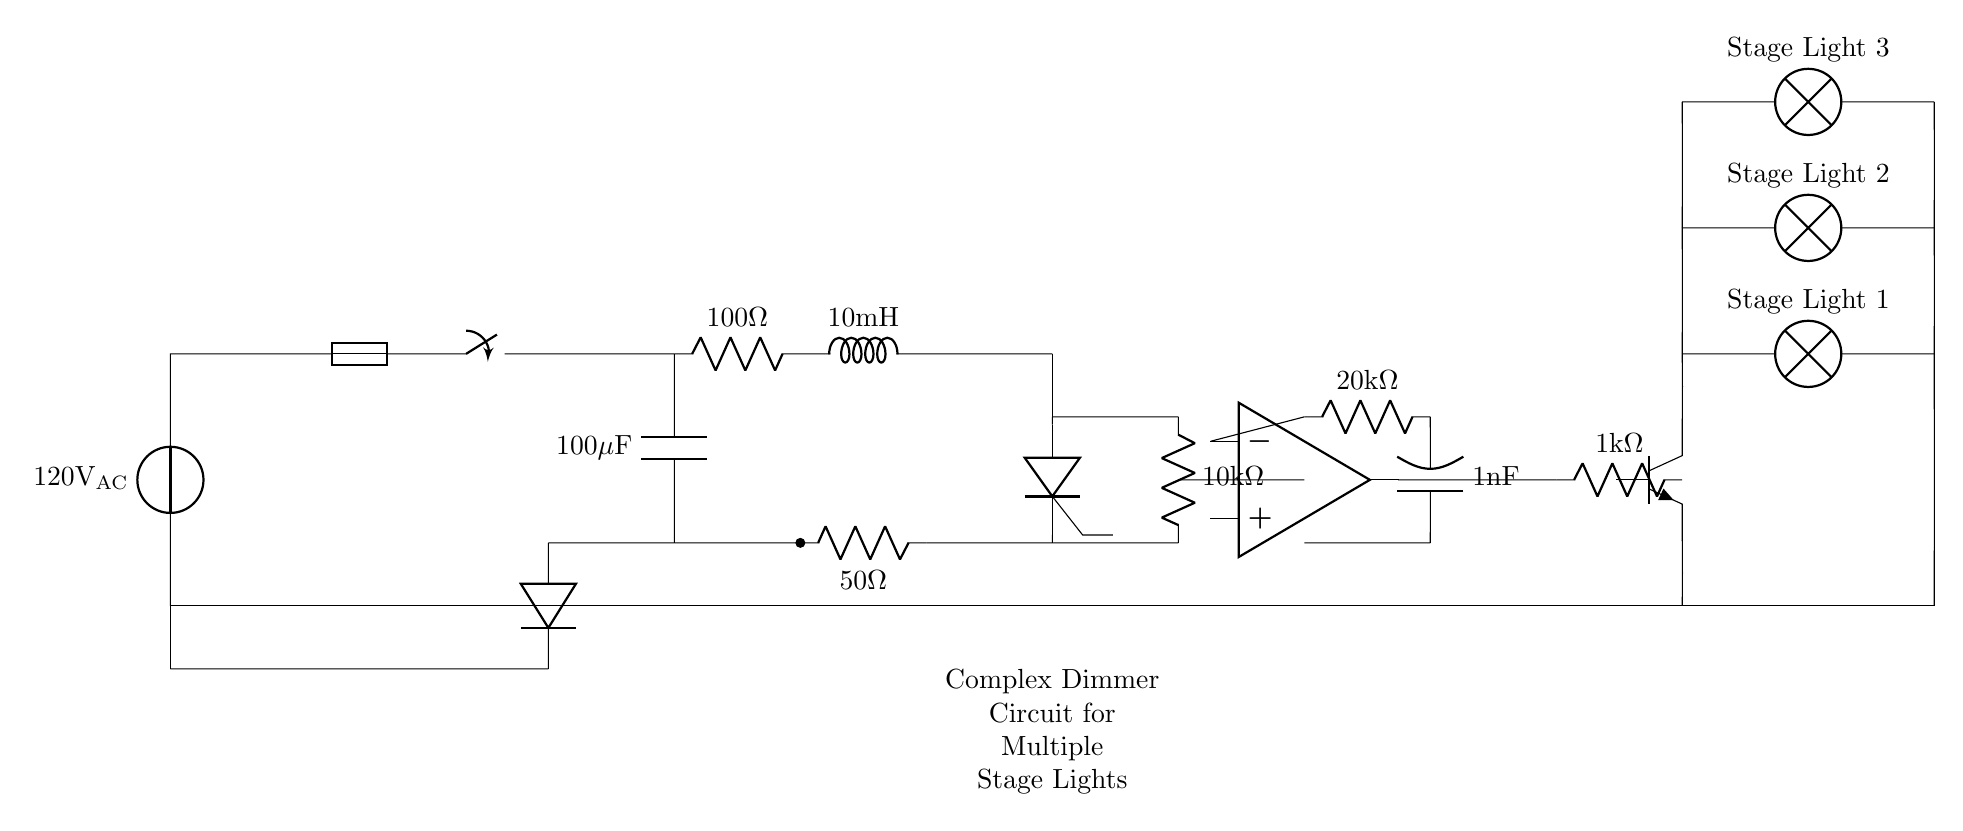What is the power source voltage? The power source voltage is indicated by the voltage source symbol at the top of the circuit. It shows a value of 120 volts AC.
Answer: 120 volts AC What type of components are connected in the circuit? The circuit is composed of a voltage source, fuse, switch, resistor, inductor, thyristor, diode, capacitor, operational amplifier, and multiple lamps.
Answer: Voltage source, fuse, switch, resistor, inductor, thyristor, diode, capacitor, operational amplifier, lamps How many lamps are controlled by the dimmer circuit? The circuit diagram shows three lamps connected in parallel with separate connections indicated by the lines leading to the lamp symbols.
Answer: Three lamps What is the function of the thyristor in this circuit? The thyristor acts as a controllable switch, allowing the current to flow to the connected lamps based on the gate control from the operational amplifier.
Answer: Controllable switch What is the resistance value of the resistor connected to the operational amplifier? The resistor connected to the operational amplifier is labeled with a value of 20 kilohms. This value can be read directly from the component label in the circuit.
Answer: 20 kilohms What is the role of the operational amplifier in the circuit? The operational amplifier amplifies the input signal and determines the gate signal to the thyristor, thereby controlling the intensity of the light output from the lamps based on the input.
Answer: Control light intensity What happens to the current if the switch is opened? When the switch is opened, it breaks the circuit, preventing current from flowing through the components, thus turning off all the lamps connected to the circuit.
Answer: Current stops 